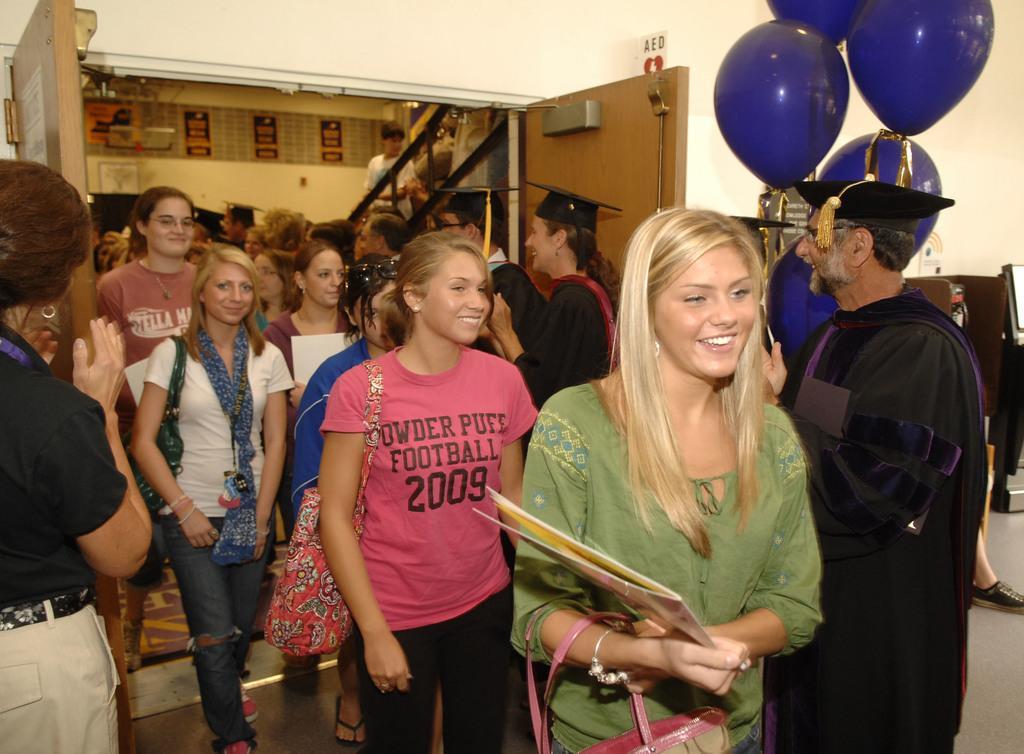Please provide a concise description of this image. In this image we can see group of persons walking on the floor. On the right side of the image we can see person and balloons. In the background we can see stairs, persons, wall and door. 